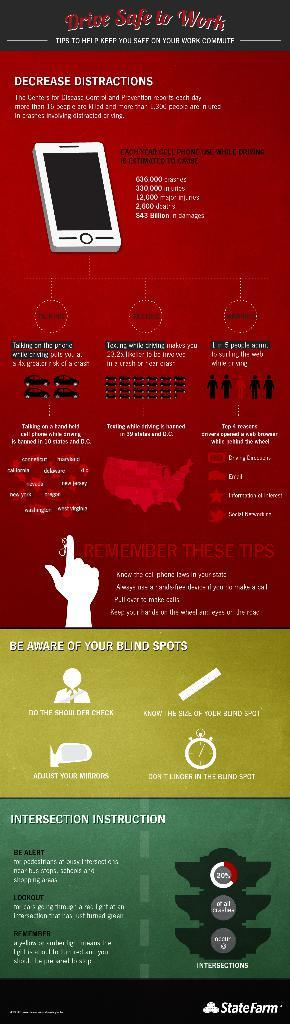What is present on the poster in the image? The poster contains text and images. Can you describe the content of the poster? The poster contains text and images, but the specific content cannot be determined from the provided facts. How many spots can be seen on the hill in the image? There is no hill or spots present in the image; it only contains a poster with text and images. 